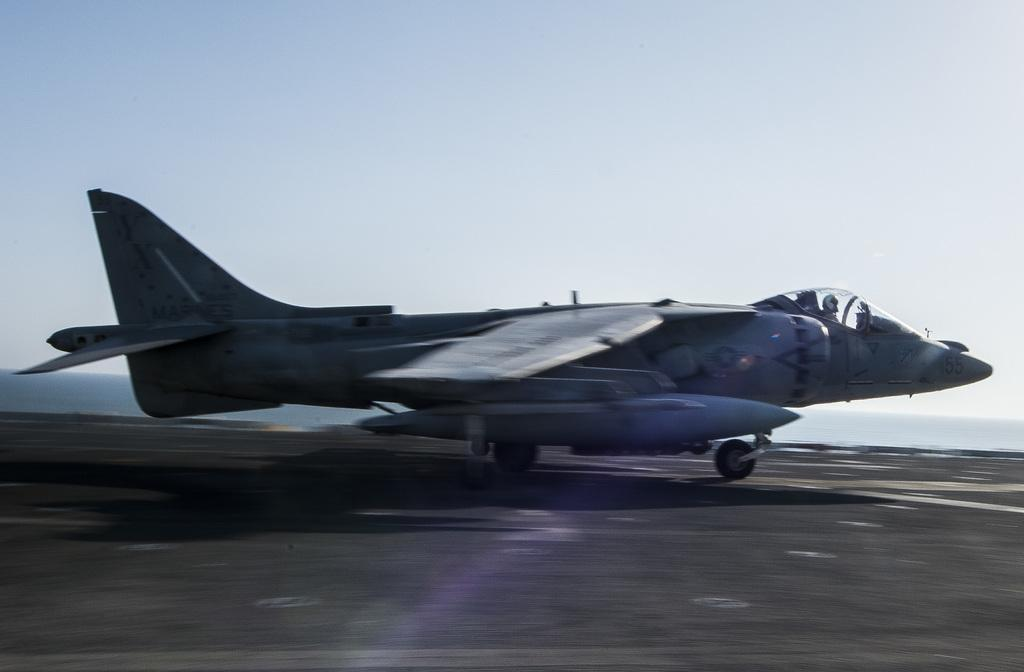What type of transportation is depicted in the image? There is an airway in the image, which is a type of transportation. What can be seen below the airway in the image? The ground is visible in the image. What is visible above the airway in the image? The sky is visible in the image. Where is the kettle located in the image? There is no kettle present in the image. What type of branch is supporting the airway in the image? There is no branch visible in the image; the airway is likely supported by a structure or tower. 